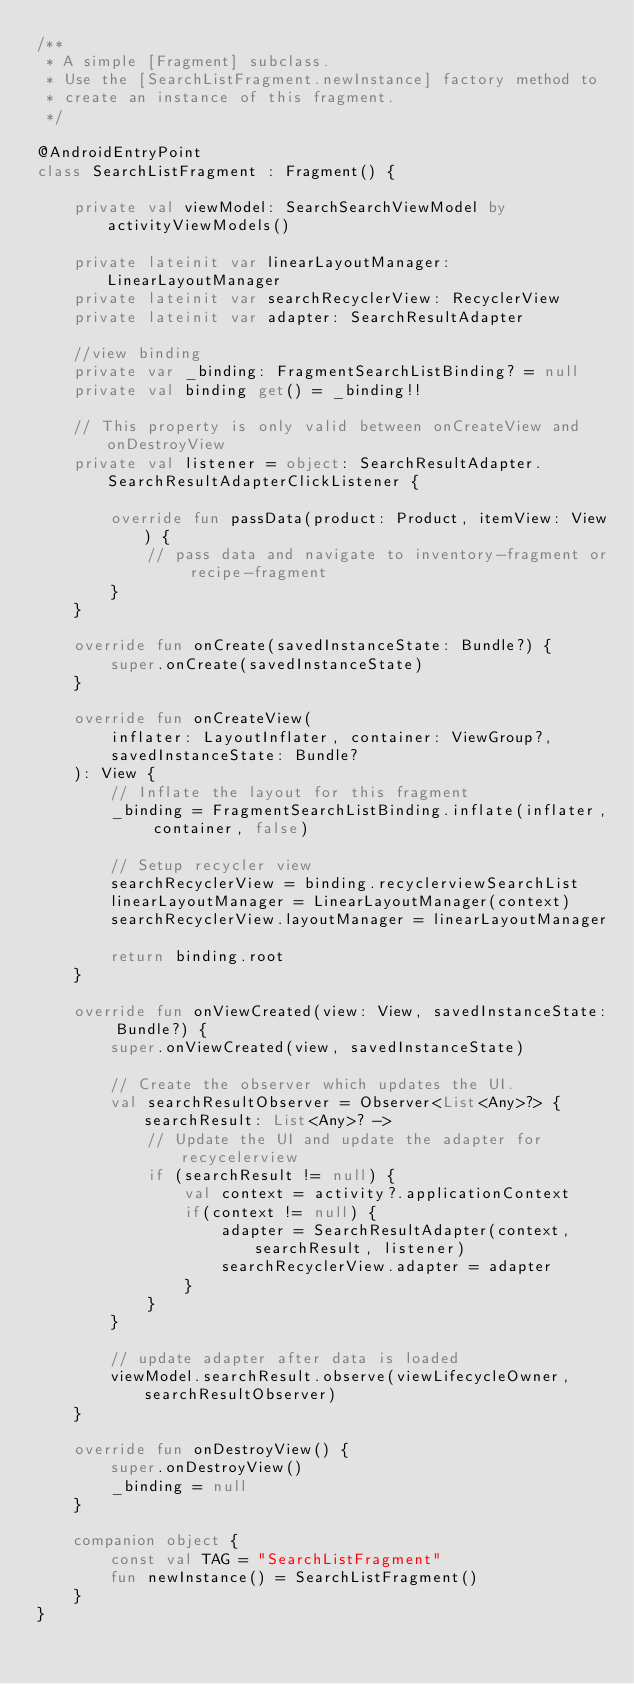<code> <loc_0><loc_0><loc_500><loc_500><_Kotlin_>/**
 * A simple [Fragment] subclass.
 * Use the [SearchListFragment.newInstance] factory method to
 * create an instance of this fragment.
 */

@AndroidEntryPoint
class SearchListFragment : Fragment() {

    private val viewModel: SearchSearchViewModel by activityViewModels()

    private lateinit var linearLayoutManager: LinearLayoutManager
    private lateinit var searchRecyclerView: RecyclerView
    private lateinit var adapter: SearchResultAdapter

    //view binding
    private var _binding: FragmentSearchListBinding? = null
    private val binding get() = _binding!!

    // This property is only valid between onCreateView and onDestroyView
    private val listener = object: SearchResultAdapter.SearchResultAdapterClickListener {

        override fun passData(product: Product, itemView: View) {
            // pass data and navigate to inventory-fragment or recipe-fragment
        }
    }

    override fun onCreate(savedInstanceState: Bundle?) {
        super.onCreate(savedInstanceState)
    }

    override fun onCreateView(
        inflater: LayoutInflater, container: ViewGroup?,
        savedInstanceState: Bundle?
    ): View {
        // Inflate the layout for this fragment
        _binding = FragmentSearchListBinding.inflate(inflater, container, false)

        // Setup recycler view
        searchRecyclerView = binding.recyclerviewSearchList
        linearLayoutManager = LinearLayoutManager(context)
        searchRecyclerView.layoutManager = linearLayoutManager

        return binding.root
    }

    override fun onViewCreated(view: View, savedInstanceState: Bundle?) {
        super.onViewCreated(view, savedInstanceState)

        // Create the observer which updates the UI.
        val searchResultObserver = Observer<List<Any>?> { searchResult: List<Any>? ->
            // Update the UI and update the adapter for recycelerview
            if (searchResult != null) {
                val context = activity?.applicationContext
                if(context != null) {
                    adapter = SearchResultAdapter(context, searchResult, listener)
                    searchRecyclerView.adapter = adapter
                }
            }
        }

        // update adapter after data is loaded
        viewModel.searchResult.observe(viewLifecycleOwner, searchResultObserver)
    }

    override fun onDestroyView() {
        super.onDestroyView()
        _binding = null
    }

    companion object {
        const val TAG = "SearchListFragment"
        fun newInstance() = SearchListFragment()
    }
}</code> 